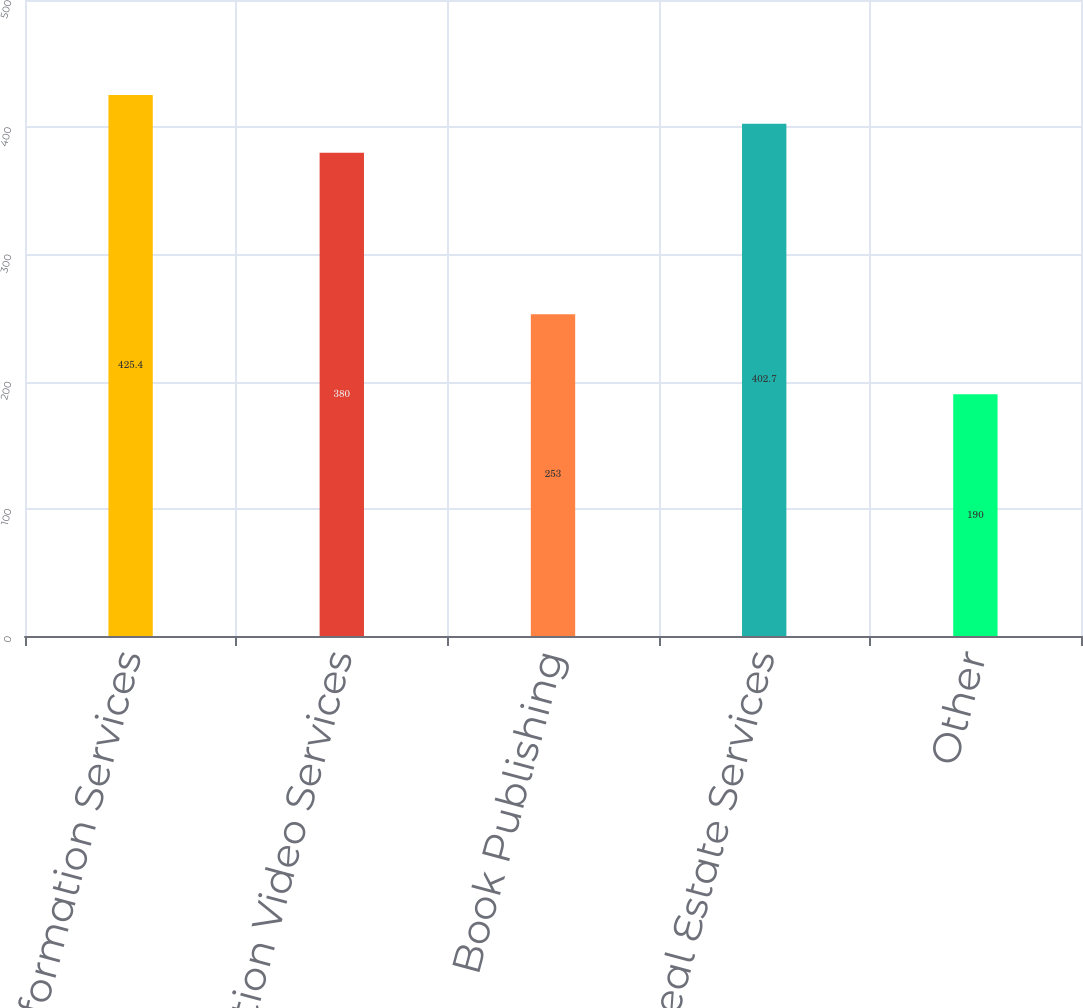<chart> <loc_0><loc_0><loc_500><loc_500><bar_chart><fcel>News and Information Services<fcel>Subscription Video Services<fcel>Book Publishing<fcel>Digital Real Estate Services<fcel>Other<nl><fcel>425.4<fcel>380<fcel>253<fcel>402.7<fcel>190<nl></chart> 